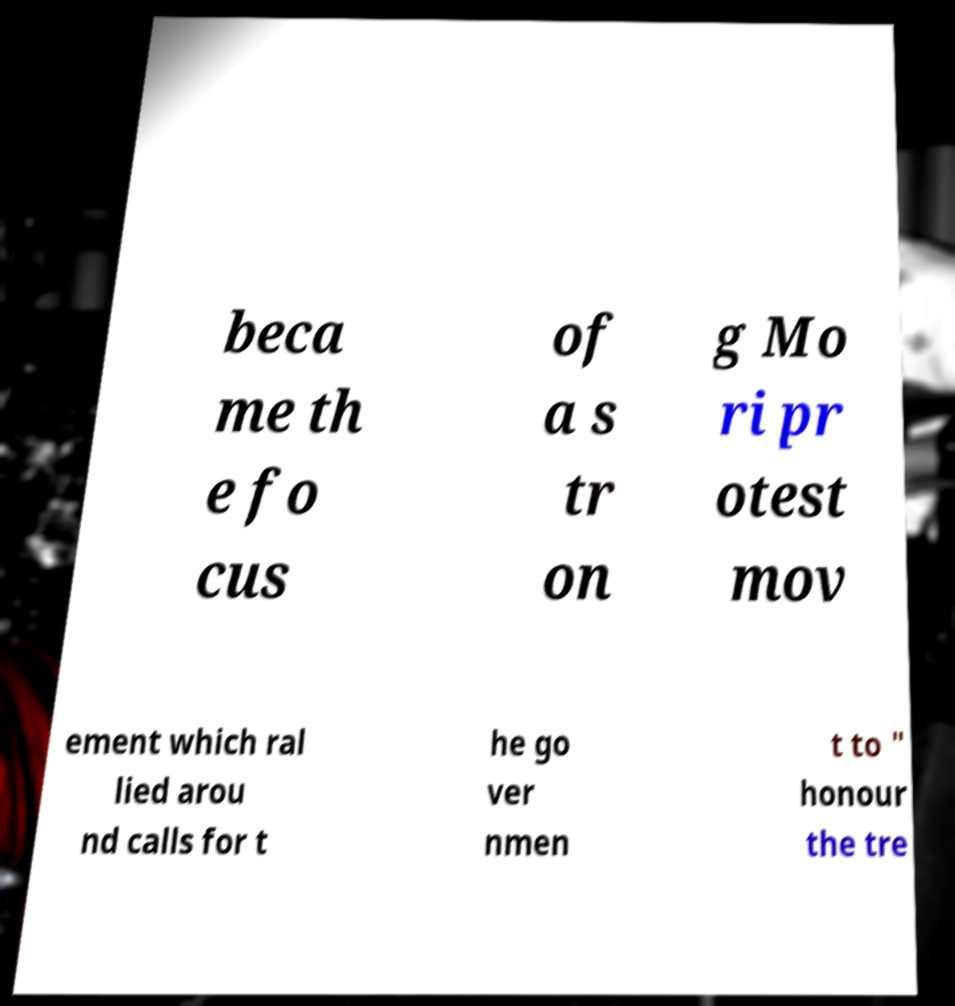Can you read and provide the text displayed in the image?This photo seems to have some interesting text. Can you extract and type it out for me? beca me th e fo cus of a s tr on g Mo ri pr otest mov ement which ral lied arou nd calls for t he go ver nmen t to " honour the tre 